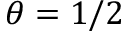<formula> <loc_0><loc_0><loc_500><loc_500>\theta = 1 / 2</formula> 